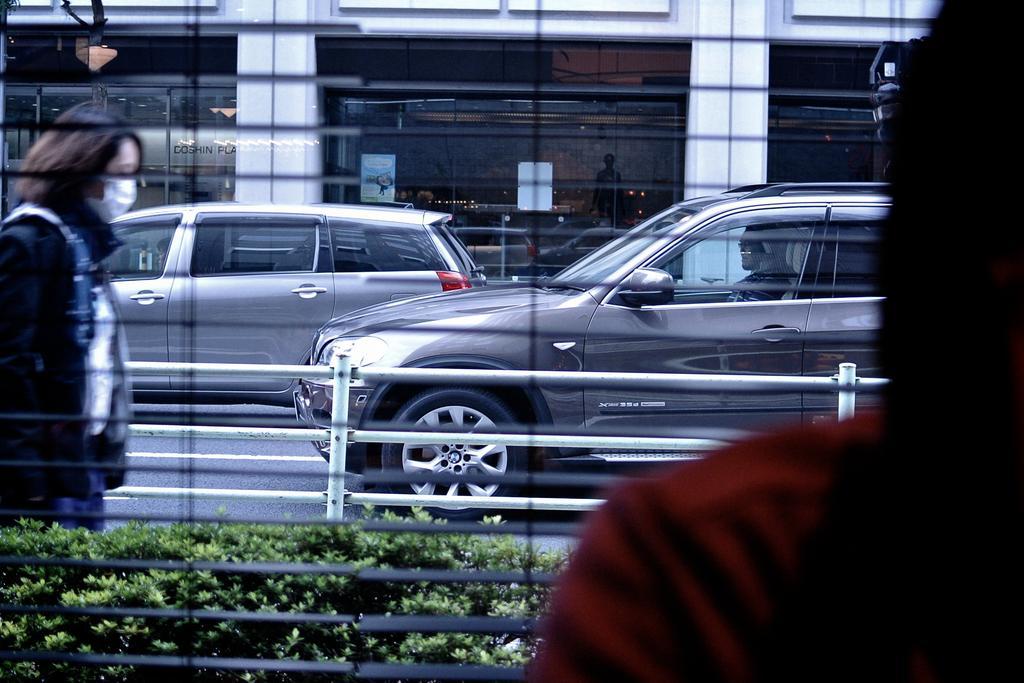Can you describe this image briefly? In this image there is a person standing in front of the window and there are few vehicles and a person on the road. In the background there is a building. 